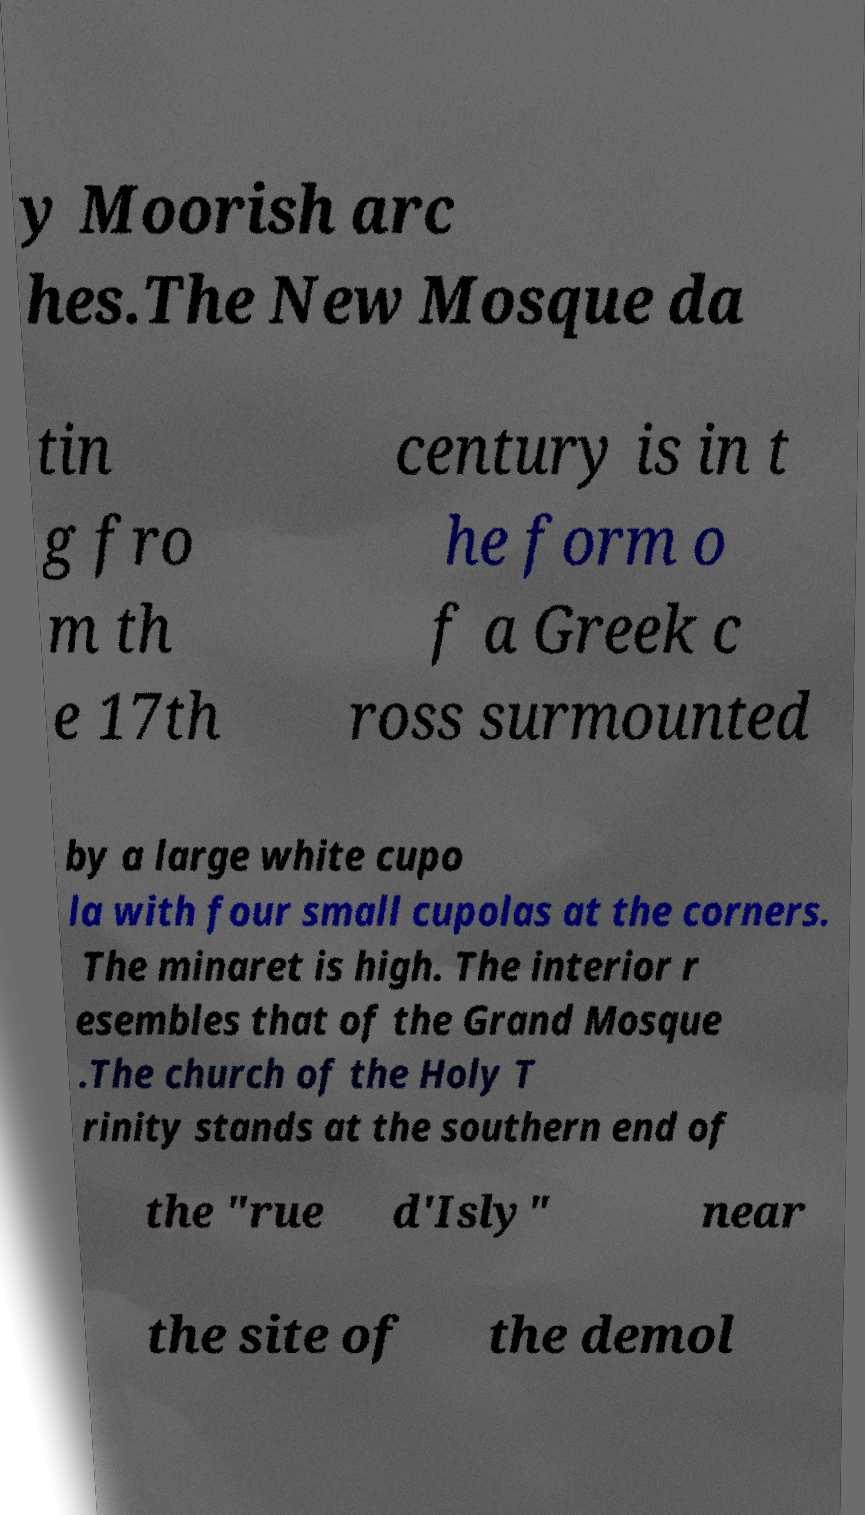Can you accurately transcribe the text from the provided image for me? y Moorish arc hes.The New Mosque da tin g fro m th e 17th century is in t he form o f a Greek c ross surmounted by a large white cupo la with four small cupolas at the corners. The minaret is high. The interior r esembles that of the Grand Mosque .The church of the Holy T rinity stands at the southern end of the "rue d'Isly" near the site of the demol 